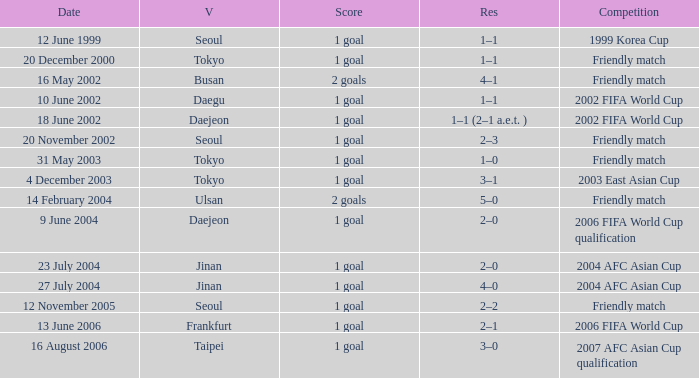What is the venue for the event on 12 November 2005? Seoul. 